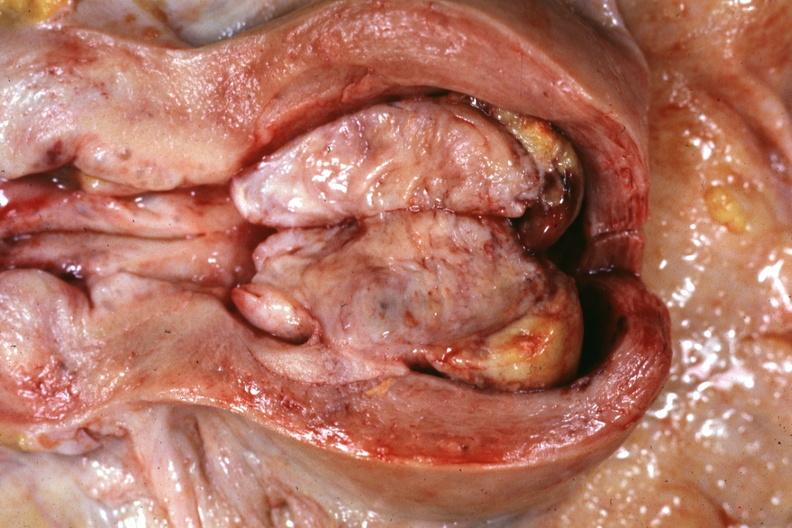s hand present?
Answer the question using a single word or phrase. No 